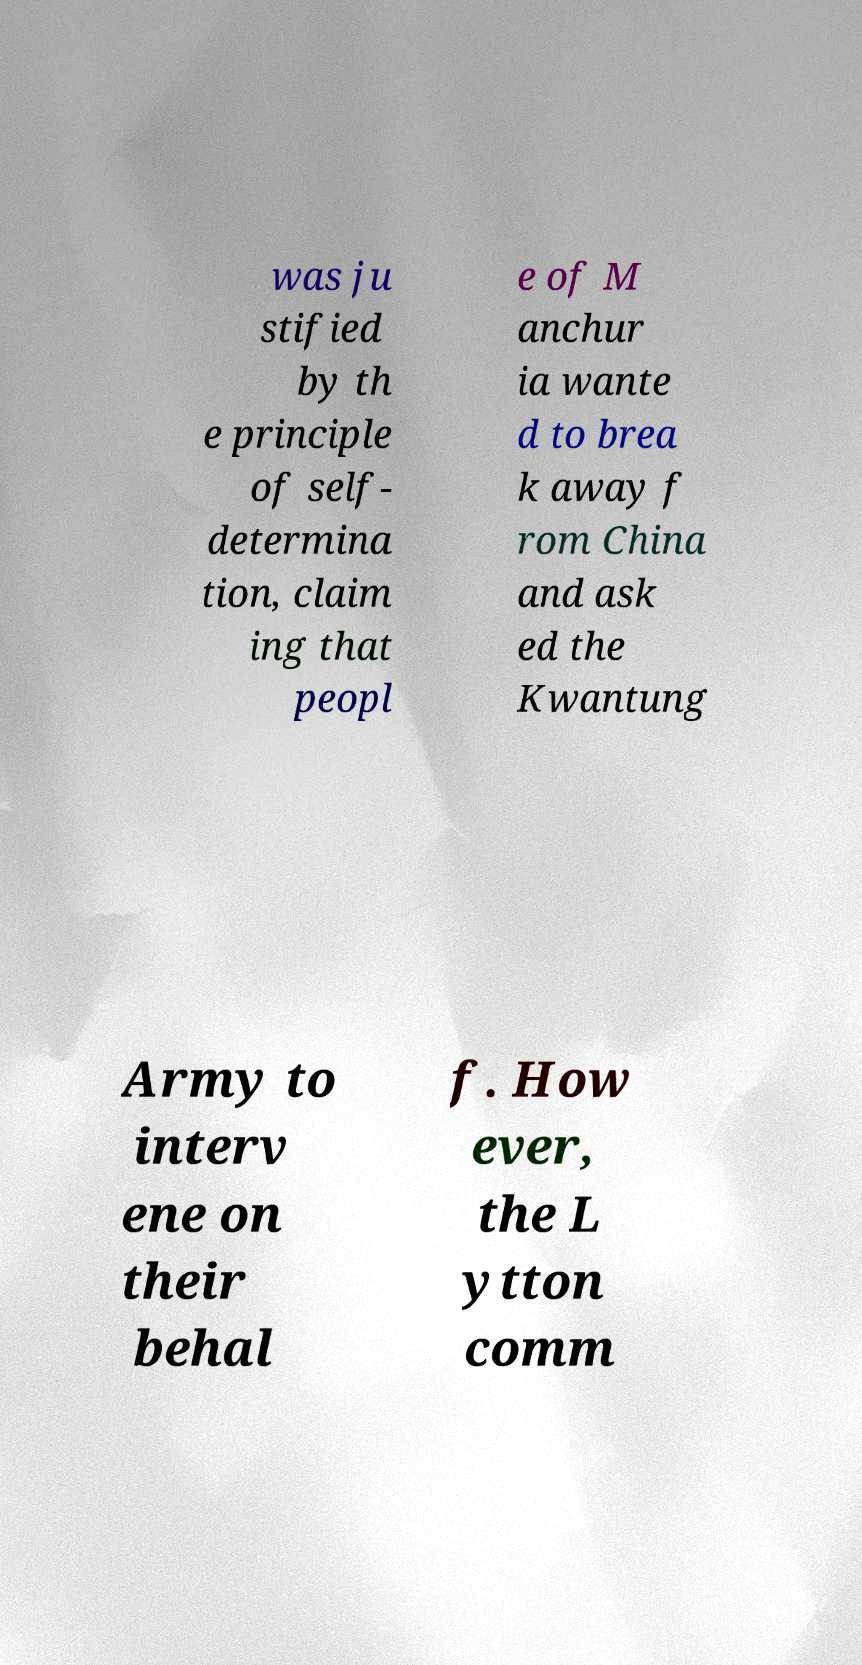Can you accurately transcribe the text from the provided image for me? was ju stified by th e principle of self- determina tion, claim ing that peopl e of M anchur ia wante d to brea k away f rom China and ask ed the Kwantung Army to interv ene on their behal f. How ever, the L ytton comm 